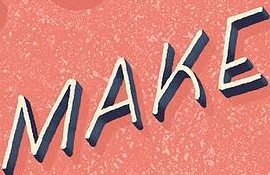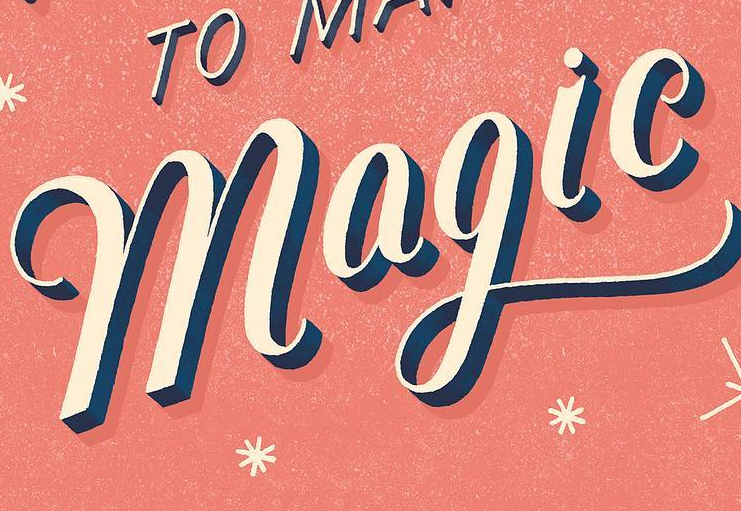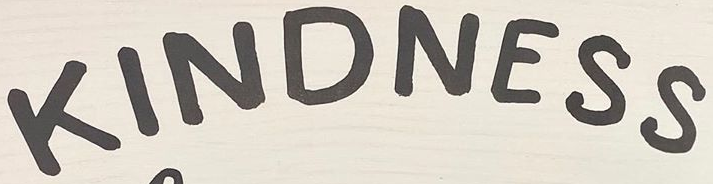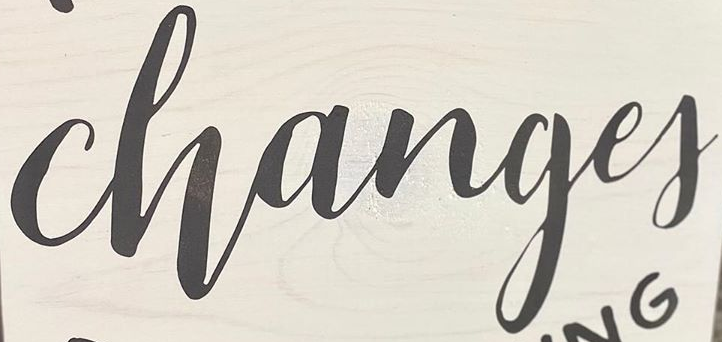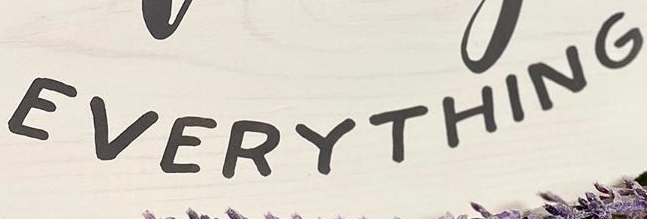What words are shown in these images in order, separated by a semicolon? MAKE; magic; KINDNESS; Changef; EVERYTHING 